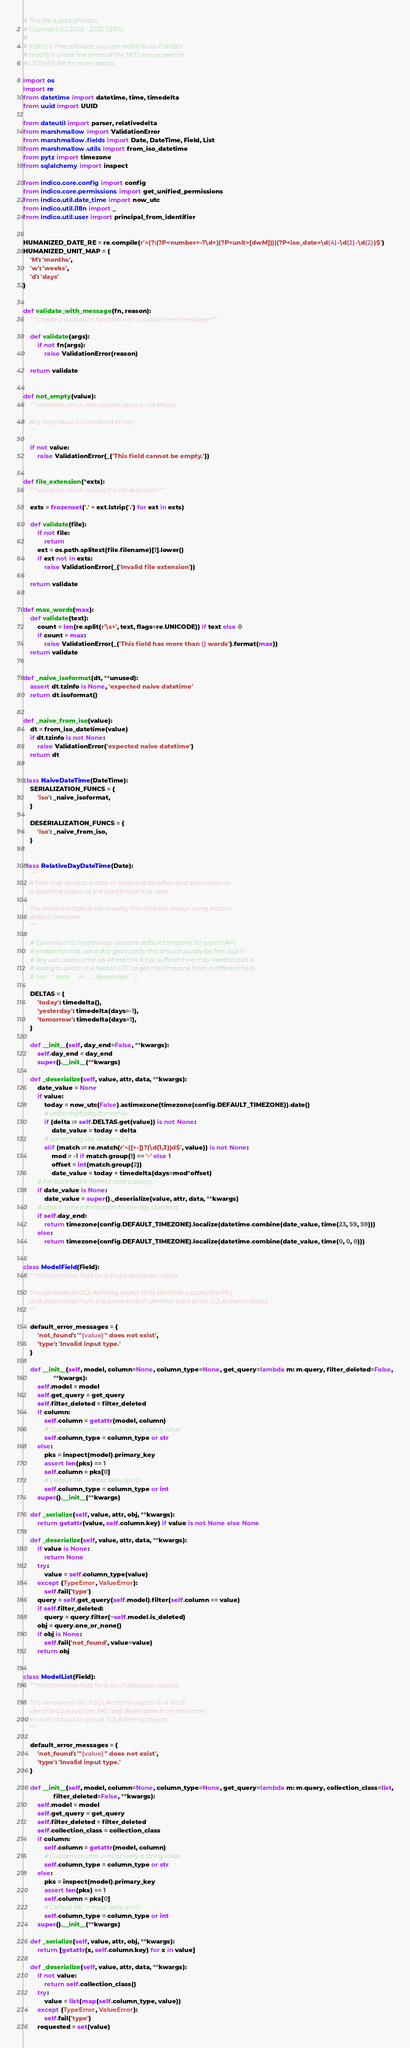Convert code to text. <code><loc_0><loc_0><loc_500><loc_500><_Python_># This file is part of Indico.
# Copyright (C) 2002 - 2022 CERN
#
# Indico is free software; you can redistribute it and/or
# modify it under the terms of the MIT License; see the
# LICENSE file for more details.

import os
import re
from datetime import datetime, time, timedelta
from uuid import UUID

from dateutil import parser, relativedelta
from marshmallow import ValidationError
from marshmallow.fields import Date, DateTime, Field, List
from marshmallow.utils import from_iso_datetime
from pytz import timezone
from sqlalchemy import inspect

from indico.core.config import config
from indico.core.permissions import get_unified_permissions
from indico.util.date_time import now_utc
from indico.util.i18n import _
from indico.util.user import principal_from_identifier


HUMANIZED_DATE_RE = re.compile(r'^(?:(?P<number>-?\d+)(?P<unit>[dwM]))|(?P<iso_date>\d{4}-\d{2}-\d{2})$')
HUMANIZED_UNIT_MAP = {
    'M': 'months',
    'w': 'weeks',
    'd': 'days'
}


def validate_with_message(fn, reason):
    """Create a validation function with a custom error message."""

    def validate(args):
        if not fn(args):
            raise ValidationError(reason)

    return validate


def not_empty(value):
    """Validator which ensures the value is not empty.

    Any falsy value is considered empty.
    """

    if not value:
        raise ValidationError(_('This field cannot be empty.'))


def file_extension(*exts):
    """Validator which checks the file extension."""

    exts = frozenset('.' + ext.lstrip('.') for ext in exts)

    def validate(file):
        if not file:
            return
        ext = os.path.splitext(file.filename)[1].lower()
        if ext not in exts:
            raise ValidationError(_('Invalid file extension'))

    return validate


def max_words(max):
    def validate(text):
        count = len(re.split(r'\s+', text, flags=re.UNICODE)) if text else 0
        if count > max:
            raise ValidationError(_('This field has more than {} words').format(max))
    return validate


def _naive_isoformat(dt, **unused):
    assert dt.tzinfo is None, 'expected naive datetime'
    return dt.isoformat()


def _naive_from_iso(value):
    dt = from_iso_datetime(value)
    if dt.tzinfo is not None:
        raise ValidationError('expected naive datetime')
    return dt


class NaiveDateTime(DateTime):
    SERIALIZATION_FUNCS = {
        'iso': _naive_isoformat,
    }

    DESERIALIZATION_FUNCS = {
        'iso': _naive_from_iso,
    }


class RelativeDayDateTime(Date):
    """
    A field that accepts a date or relative date offset and deserializes to
    a datetime object at the start/end of that date.

    The datetime objects returned by this field are always using Indico's
    default timezone.
    """

    # Currently this field always uses the default timezone; for typical API
    # endpoints that use a day granularity this should usually be fine, but if
    # any use cases come up where this is not sufficient we may need to add a
    # kwarg to switch the field to UTC or get the timezone from a different field
    # (via ``data`` in ``_deserialize``)

    DELTAS = {
        'today': timedelta(),
        'yesterday': timedelta(days=-1),
        'tomorrow': timedelta(days=1),
    }

    def __init__(self, day_end=False, **kwargs):
        self.day_end = day_end
        super().__init__(**kwargs)

    def _deserialize(self, value, attr, data, **kwargs):
        date_value = None
        if value:
            today = now_utc(False).astimezone(timezone(config.DEFAULT_TIMEZONE)).date()
            # yesterday/today/tomorrow
            if (delta := self.DELTAS.get(value)) is not None:
                date_value = today + delta
            # something like -14d or +7d
            elif (match := re.match(r'^([+-])?(\d{1,3})d$', value)) is not None:
                mod = -1 if match.group(1) == '-' else 1
                offset = int(match.group(2))
                date_value = today + timedelta(days=mod*offset)
        # fall back to the normal date parsing
        if date_value is None:
            date_value = super()._deserialize(value, attr, data, **kwargs)
        # attach time information for the day start/end
        if self.day_end:
            return timezone(config.DEFAULT_TIMEZONE).localize(datetime.combine(date_value, time(23, 59, 59)))
        else:
            return timezone(config.DEFAULT_TIMEZONE).localize(datetime.combine(date_value, time(0, 0, 0)))


class ModelField(Field):
    """Marshmallow field for a single database object.

    This serializes an SQLAlchemy object to its identifier (usually the PK),
    and deserializes from the same kind of identifier back to an SQLAlchemy object.
    """

    default_error_messages = {
        'not_found': '"{value}" does not exist',
        'type': 'Invalid input type.'
    }

    def __init__(self, model, column=None, column_type=None, get_query=lambda m: m.query, filter_deleted=False,
                 **kwargs):
        self.model = model
        self.get_query = get_query
        self.filter_deleted = filter_deleted
        if column:
            self.column = getattr(model, column)
            # Custom column -> most likely a string value
            self.column_type = column_type or str
        else:
            pks = inspect(model).primary_key
            assert len(pks) == 1
            self.column = pks[0]
            # Default PK -> most likely an ID
            self.column_type = column_type or int
        super().__init__(**kwargs)

    def _serialize(self, value, attr, obj, **kwargs):
        return getattr(value, self.column.key) if value is not None else None

    def _deserialize(self, value, attr, data, **kwargs):
        if value is None:
            return None
        try:
            value = self.column_type(value)
        except (TypeError, ValueError):
            self.fail('type')
        query = self.get_query(self.model).filter(self.column == value)
        if self.filter_deleted:
            query = query.filter(~self.model.is_deleted)
        obj = query.one_or_none()
        if obj is None:
            self.fail('not_found', value=value)
        return obj


class ModelList(Field):
    """Marshmallow field for a list of database objects.

    This serializes a list of SQLAlchemy objects to a list of
    identifiers (usually the PK), and deserializes from the same
    kind of list back to actual SQLAlchemy objects.
    """

    default_error_messages = {
        'not_found': '"{value}" does not exist',
        'type': 'Invalid input type.'
    }

    def __init__(self, model, column=None, column_type=None, get_query=lambda m: m.query, collection_class=list,
                 filter_deleted=False, **kwargs):
        self.model = model
        self.get_query = get_query
        self.filter_deleted = filter_deleted
        self.collection_class = collection_class
        if column:
            self.column = getattr(model, column)
            # Custom column -> most likely a string value
            self.column_type = column_type or str
        else:
            pks = inspect(model).primary_key
            assert len(pks) == 1
            self.column = pks[0]
            # Default PK -> most likely an ID
            self.column_type = column_type or int
        super().__init__(**kwargs)

    def _serialize(self, value, attr, obj, **kwargs):
        return [getattr(x, self.column.key) for x in value]

    def _deserialize(self, value, attr, data, **kwargs):
        if not value:
            return self.collection_class()
        try:
            value = list(map(self.column_type, value))
        except (TypeError, ValueError):
            self.fail('type')
        requested = set(value)</code> 